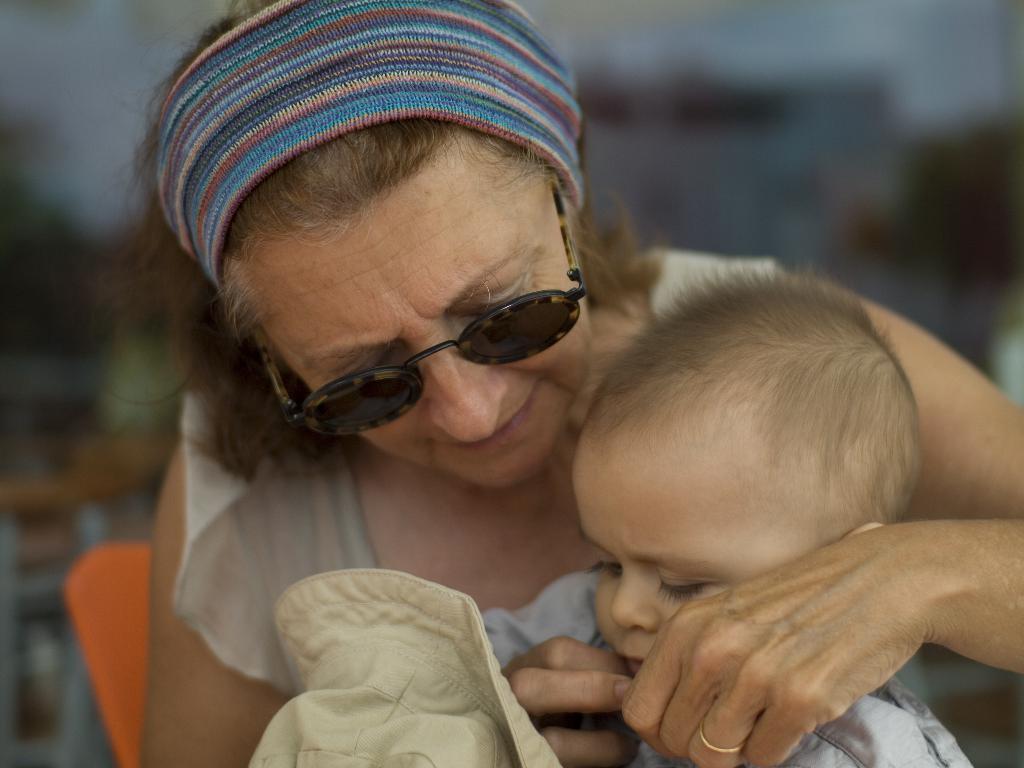Could you give a brief overview of what you see in this image? In the picture we can see a woman wearing headband, goggles holding a kid in her hands who is holding hat. 